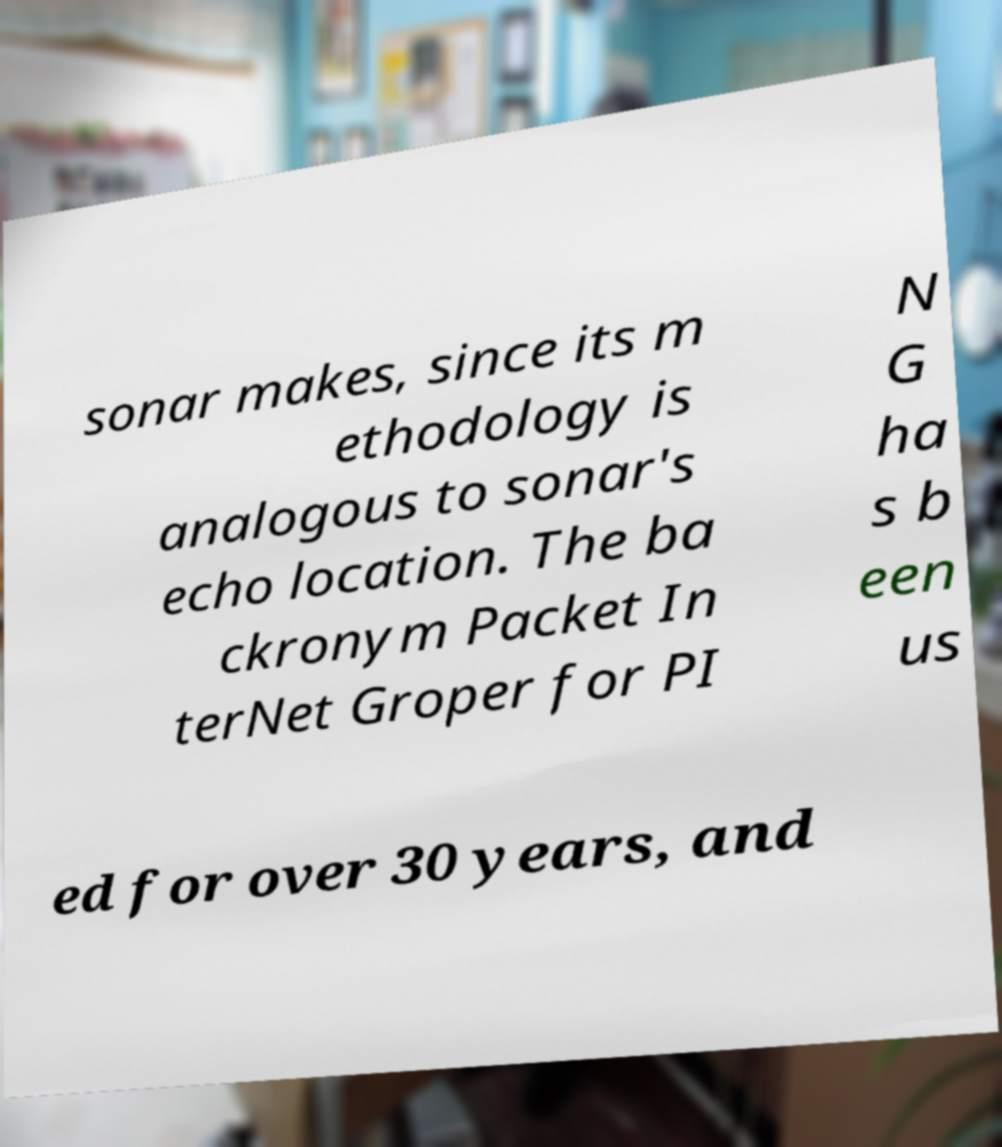What messages or text are displayed in this image? I need them in a readable, typed format. sonar makes, since its m ethodology is analogous to sonar's echo location. The ba ckronym Packet In terNet Groper for PI N G ha s b een us ed for over 30 years, and 